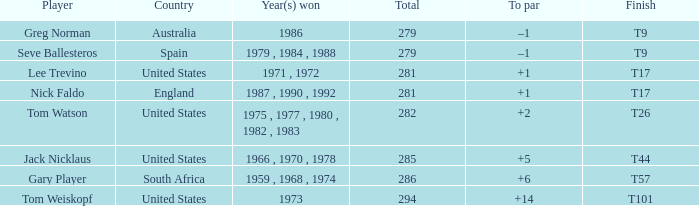Who holds the highest overall total with a +14 to par? 294.0. 